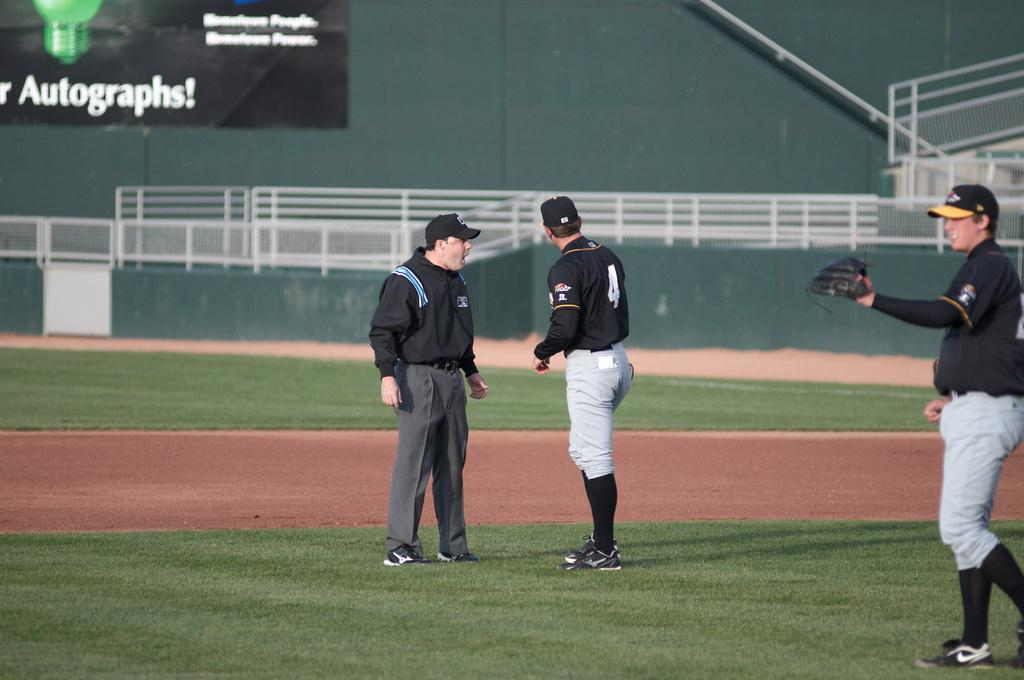Provide a one-sentence caption for the provided image. 2 baseball players on the field, with number 2 talking to the coach in front of a sign that advertises Autographs!. 